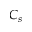<formula> <loc_0><loc_0><loc_500><loc_500>C _ { s }</formula> 